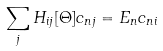Convert formula to latex. <formula><loc_0><loc_0><loc_500><loc_500>\sum _ { j } H _ { i j } [ \Theta ] c _ { n j } = E _ { n } c _ { n i }</formula> 